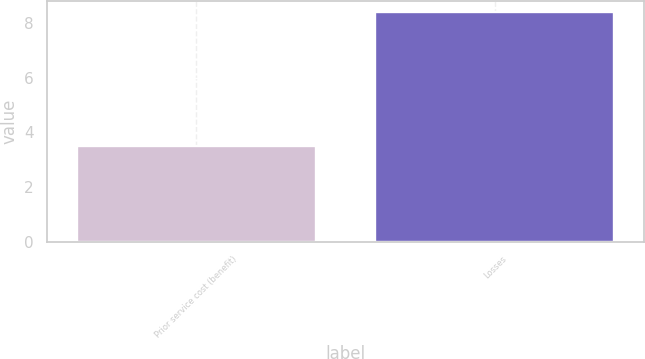<chart> <loc_0><loc_0><loc_500><loc_500><bar_chart><fcel>Prior service cost (benefit)<fcel>Losses<nl><fcel>3.5<fcel>8.4<nl></chart> 